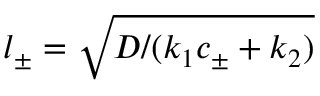Convert formula to latex. <formula><loc_0><loc_0><loc_500><loc_500>{ l _ { \pm } = \sqrt { D / ( k _ { 1 } c _ { \pm } + k _ { 2 } ) } }</formula> 